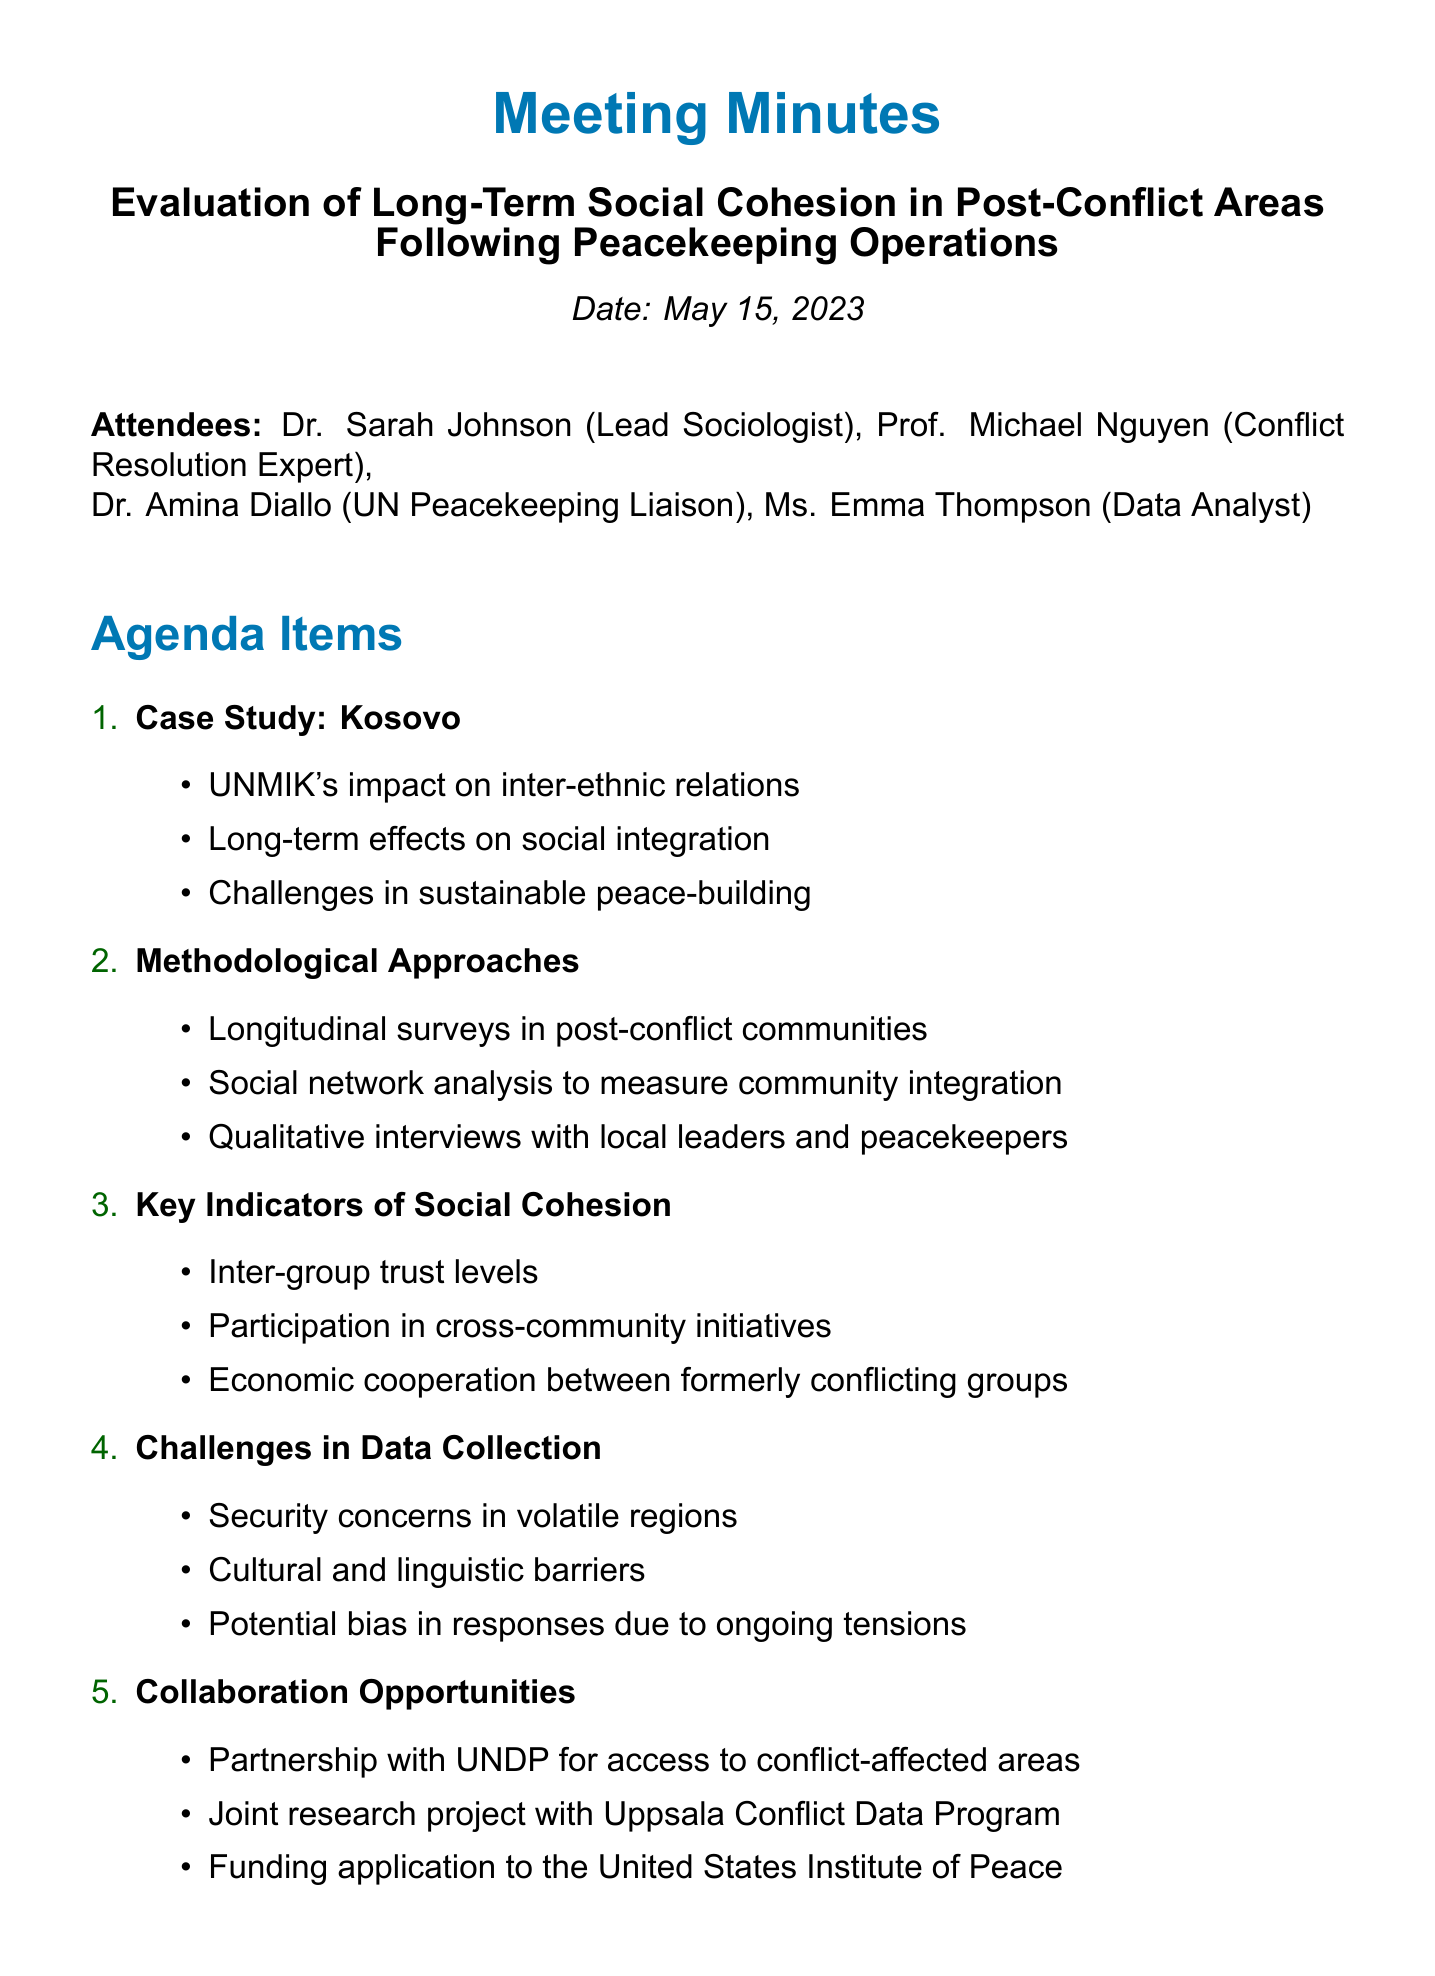What is the meeting date? The meeting date is explicitly stated in the document.
Answer: May 15, 2023 Who is the Lead Sociologist? The document lists the attendees and their roles, identifying the Lead Sociologist.
Answer: Dr. Sarah Johnson What is one key indicator of social cohesion mentioned? The document highlights several key indicators under the respective agenda item.
Answer: Inter-group trust levels What are the challenges in data collection? The meeting minutes outline specific challenges faced in data collection under the respective agenda item.
Answer: Security concerns in volatile regions What is the next meeting date? The next meeting date is provided at the end of the document.
Answer: June 15, 2023 Who will develop data collection tools? The action items specify responsibilities assigned to attendees.
Answer: Ms. Thompson What case study is referenced in the meeting? The agenda items include a section on a specific case study being discussed.
Answer: Kosovo What type of approach is mentioned for measuring community integration? The methodological approaches section includes specific methodologies for evaluation.
Answer: Social network analysis 